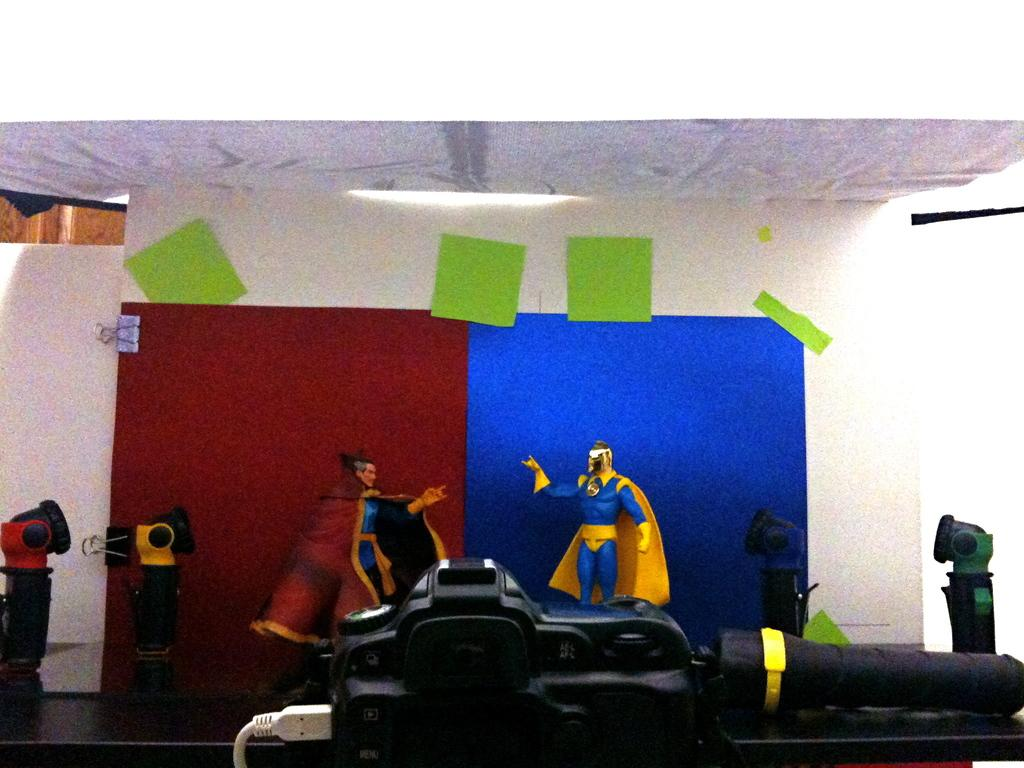What type of toys are present in the image? There are superhero toys in the image. What office supply items can be seen in the image? There are paper clips in the image. What type of stationery items are visible in the image? There are colorful papers in the image. What else can be found on the table in the image? There are other things on the table in the image. What color is the daughter's hair in the image? There is no daughter present in the image. How many nails are visible in the image? There are no nails visible in the image. 